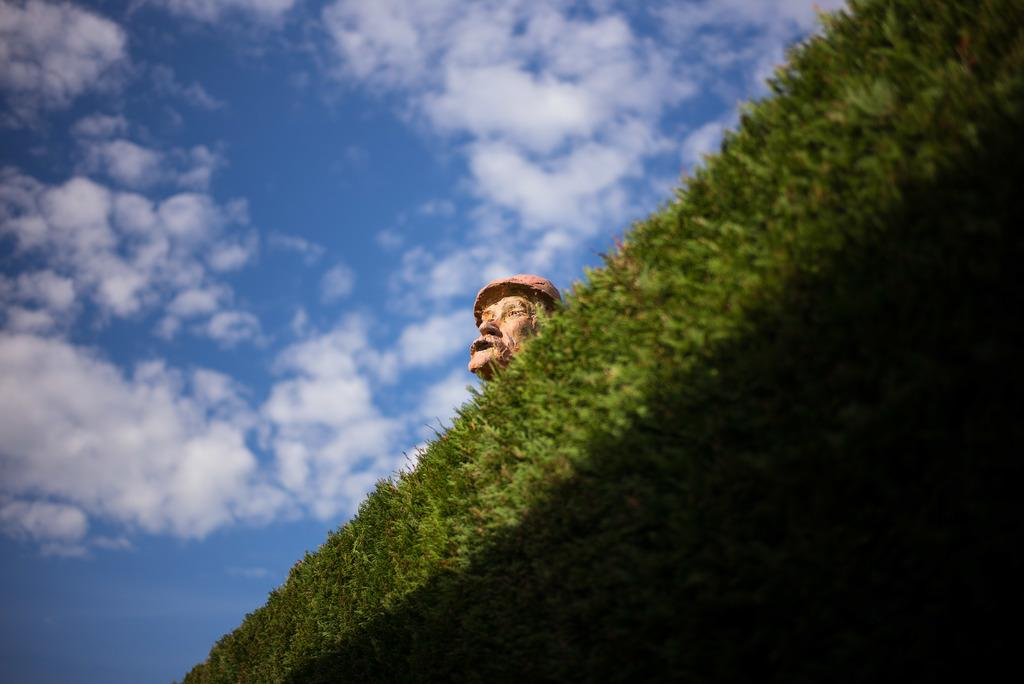Where was the image taken? The image was clicked outside. What can be seen in the foreground of the image? There is green grass and a sculpture of a person in the foreground of the image. What is visible in the background of the image? The sky is visible in the background of the image. What can be observed in the sky? Clouds are present in the sky. How many dolls are sitting on the twig in the image? There are no dolls or twigs present in the image. 